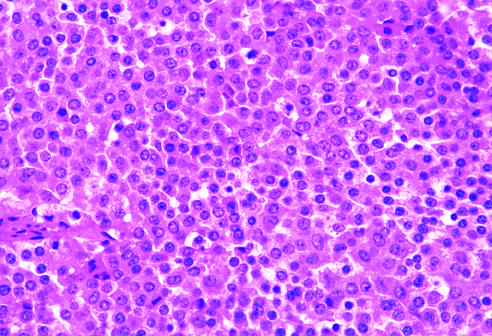does cm contrast with the admixture of cells seen in the normal anterior pituitary gland?
Answer the question using a single word or phrase. No 